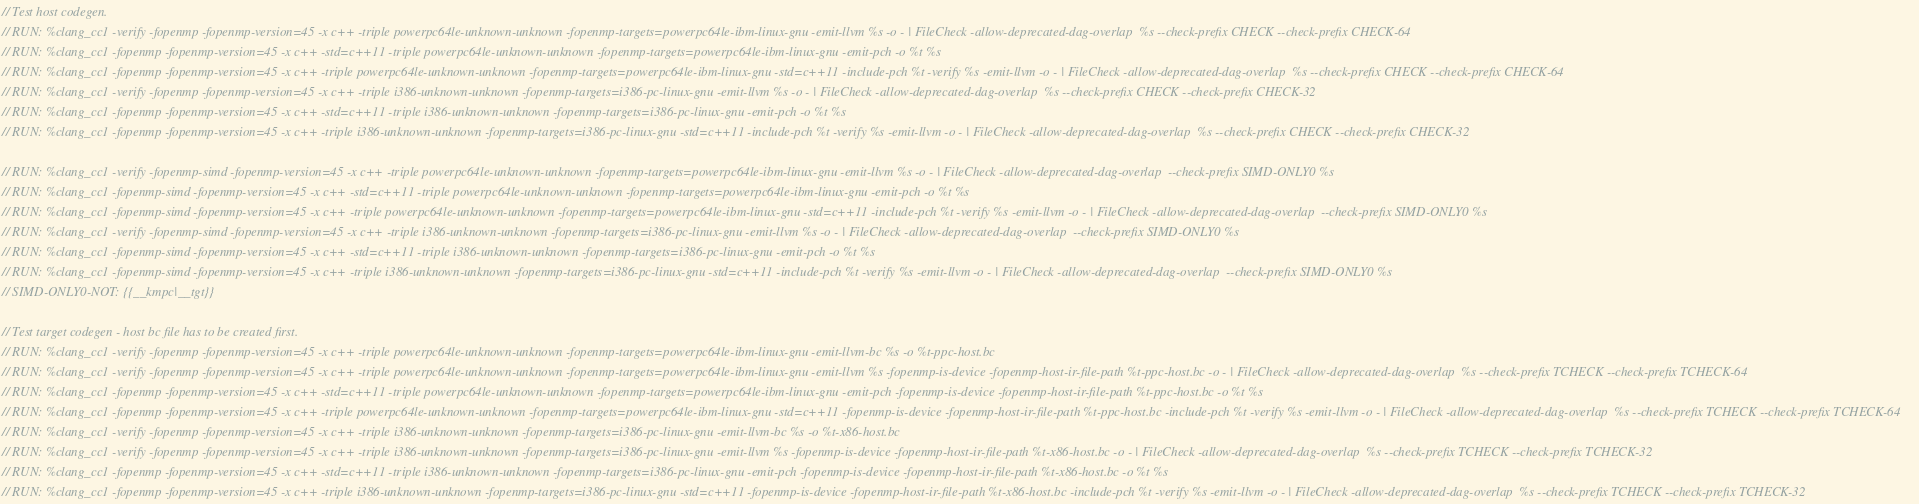Convert code to text. <code><loc_0><loc_0><loc_500><loc_500><_C++_>// Test host codegen.
// RUN: %clang_cc1 -verify -fopenmp -fopenmp-version=45 -x c++ -triple powerpc64le-unknown-unknown -fopenmp-targets=powerpc64le-ibm-linux-gnu -emit-llvm %s -o - | FileCheck -allow-deprecated-dag-overlap  %s --check-prefix CHECK --check-prefix CHECK-64
// RUN: %clang_cc1 -fopenmp -fopenmp-version=45 -x c++ -std=c++11 -triple powerpc64le-unknown-unknown -fopenmp-targets=powerpc64le-ibm-linux-gnu -emit-pch -o %t %s
// RUN: %clang_cc1 -fopenmp -fopenmp-version=45 -x c++ -triple powerpc64le-unknown-unknown -fopenmp-targets=powerpc64le-ibm-linux-gnu -std=c++11 -include-pch %t -verify %s -emit-llvm -o - | FileCheck -allow-deprecated-dag-overlap  %s --check-prefix CHECK --check-prefix CHECK-64
// RUN: %clang_cc1 -verify -fopenmp -fopenmp-version=45 -x c++ -triple i386-unknown-unknown -fopenmp-targets=i386-pc-linux-gnu -emit-llvm %s -o - | FileCheck -allow-deprecated-dag-overlap  %s --check-prefix CHECK --check-prefix CHECK-32
// RUN: %clang_cc1 -fopenmp -fopenmp-version=45 -x c++ -std=c++11 -triple i386-unknown-unknown -fopenmp-targets=i386-pc-linux-gnu -emit-pch -o %t %s
// RUN: %clang_cc1 -fopenmp -fopenmp-version=45 -x c++ -triple i386-unknown-unknown -fopenmp-targets=i386-pc-linux-gnu -std=c++11 -include-pch %t -verify %s -emit-llvm -o - | FileCheck -allow-deprecated-dag-overlap  %s --check-prefix CHECK --check-prefix CHECK-32

// RUN: %clang_cc1 -verify -fopenmp-simd -fopenmp-version=45 -x c++ -triple powerpc64le-unknown-unknown -fopenmp-targets=powerpc64le-ibm-linux-gnu -emit-llvm %s -o - | FileCheck -allow-deprecated-dag-overlap  --check-prefix SIMD-ONLY0 %s
// RUN: %clang_cc1 -fopenmp-simd -fopenmp-version=45 -x c++ -std=c++11 -triple powerpc64le-unknown-unknown -fopenmp-targets=powerpc64le-ibm-linux-gnu -emit-pch -o %t %s
// RUN: %clang_cc1 -fopenmp-simd -fopenmp-version=45 -x c++ -triple powerpc64le-unknown-unknown -fopenmp-targets=powerpc64le-ibm-linux-gnu -std=c++11 -include-pch %t -verify %s -emit-llvm -o - | FileCheck -allow-deprecated-dag-overlap  --check-prefix SIMD-ONLY0 %s
// RUN: %clang_cc1 -verify -fopenmp-simd -fopenmp-version=45 -x c++ -triple i386-unknown-unknown -fopenmp-targets=i386-pc-linux-gnu -emit-llvm %s -o - | FileCheck -allow-deprecated-dag-overlap  --check-prefix SIMD-ONLY0 %s
// RUN: %clang_cc1 -fopenmp-simd -fopenmp-version=45 -x c++ -std=c++11 -triple i386-unknown-unknown -fopenmp-targets=i386-pc-linux-gnu -emit-pch -o %t %s
// RUN: %clang_cc1 -fopenmp-simd -fopenmp-version=45 -x c++ -triple i386-unknown-unknown -fopenmp-targets=i386-pc-linux-gnu -std=c++11 -include-pch %t -verify %s -emit-llvm -o - | FileCheck -allow-deprecated-dag-overlap  --check-prefix SIMD-ONLY0 %s
// SIMD-ONLY0-NOT: {{__kmpc|__tgt}}

// Test target codegen - host bc file has to be created first.
// RUN: %clang_cc1 -verify -fopenmp -fopenmp-version=45 -x c++ -triple powerpc64le-unknown-unknown -fopenmp-targets=powerpc64le-ibm-linux-gnu -emit-llvm-bc %s -o %t-ppc-host.bc
// RUN: %clang_cc1 -verify -fopenmp -fopenmp-version=45 -x c++ -triple powerpc64le-unknown-unknown -fopenmp-targets=powerpc64le-ibm-linux-gnu -emit-llvm %s -fopenmp-is-device -fopenmp-host-ir-file-path %t-ppc-host.bc -o - | FileCheck -allow-deprecated-dag-overlap  %s --check-prefix TCHECK --check-prefix TCHECK-64
// RUN: %clang_cc1 -fopenmp -fopenmp-version=45 -x c++ -std=c++11 -triple powerpc64le-unknown-unknown -fopenmp-targets=powerpc64le-ibm-linux-gnu -emit-pch -fopenmp-is-device -fopenmp-host-ir-file-path %t-ppc-host.bc -o %t %s
// RUN: %clang_cc1 -fopenmp -fopenmp-version=45 -x c++ -triple powerpc64le-unknown-unknown -fopenmp-targets=powerpc64le-ibm-linux-gnu -std=c++11 -fopenmp-is-device -fopenmp-host-ir-file-path %t-ppc-host.bc -include-pch %t -verify %s -emit-llvm -o - | FileCheck -allow-deprecated-dag-overlap  %s --check-prefix TCHECK --check-prefix TCHECK-64
// RUN: %clang_cc1 -verify -fopenmp -fopenmp-version=45 -x c++ -triple i386-unknown-unknown -fopenmp-targets=i386-pc-linux-gnu -emit-llvm-bc %s -o %t-x86-host.bc
// RUN: %clang_cc1 -verify -fopenmp -fopenmp-version=45 -x c++ -triple i386-unknown-unknown -fopenmp-targets=i386-pc-linux-gnu -emit-llvm %s -fopenmp-is-device -fopenmp-host-ir-file-path %t-x86-host.bc -o - | FileCheck -allow-deprecated-dag-overlap  %s --check-prefix TCHECK --check-prefix TCHECK-32
// RUN: %clang_cc1 -fopenmp -fopenmp-version=45 -x c++ -std=c++11 -triple i386-unknown-unknown -fopenmp-targets=i386-pc-linux-gnu -emit-pch -fopenmp-is-device -fopenmp-host-ir-file-path %t-x86-host.bc -o %t %s
// RUN: %clang_cc1 -fopenmp -fopenmp-version=45 -x c++ -triple i386-unknown-unknown -fopenmp-targets=i386-pc-linux-gnu -std=c++11 -fopenmp-is-device -fopenmp-host-ir-file-path %t-x86-host.bc -include-pch %t -verify %s -emit-llvm -o - | FileCheck -allow-deprecated-dag-overlap  %s --check-prefix TCHECK --check-prefix TCHECK-32
</code> 